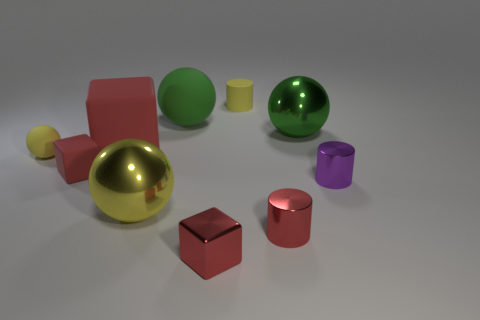Are there any cylinders that are behind the yellow ball on the left side of the large red object?
Offer a terse response. Yes. How many balls are green objects or tiny red rubber objects?
Offer a terse response. 2. What size is the red block in front of the small metal thing right of the tiny red metallic thing on the right side of the tiny rubber cylinder?
Ensure brevity in your answer.  Small. Are there any purple metallic things on the left side of the big green rubber ball?
Offer a terse response. No. What is the shape of the large thing that is the same color as the matte cylinder?
Give a very brief answer. Sphere. What number of things are large shiny balls that are on the right side of the small red metal cylinder or blue shiny objects?
Offer a terse response. 1. There is a green object that is the same material as the tiny ball; what size is it?
Keep it short and to the point. Large. There is a red metallic cylinder; is it the same size as the green thing on the left side of the tiny matte cylinder?
Ensure brevity in your answer.  No. What color is the block that is both behind the small shiny block and on the right side of the tiny rubber cube?
Keep it short and to the point. Red. How many things are tiny red blocks left of the big rubber sphere or big objects in front of the green shiny ball?
Your answer should be very brief. 3. 